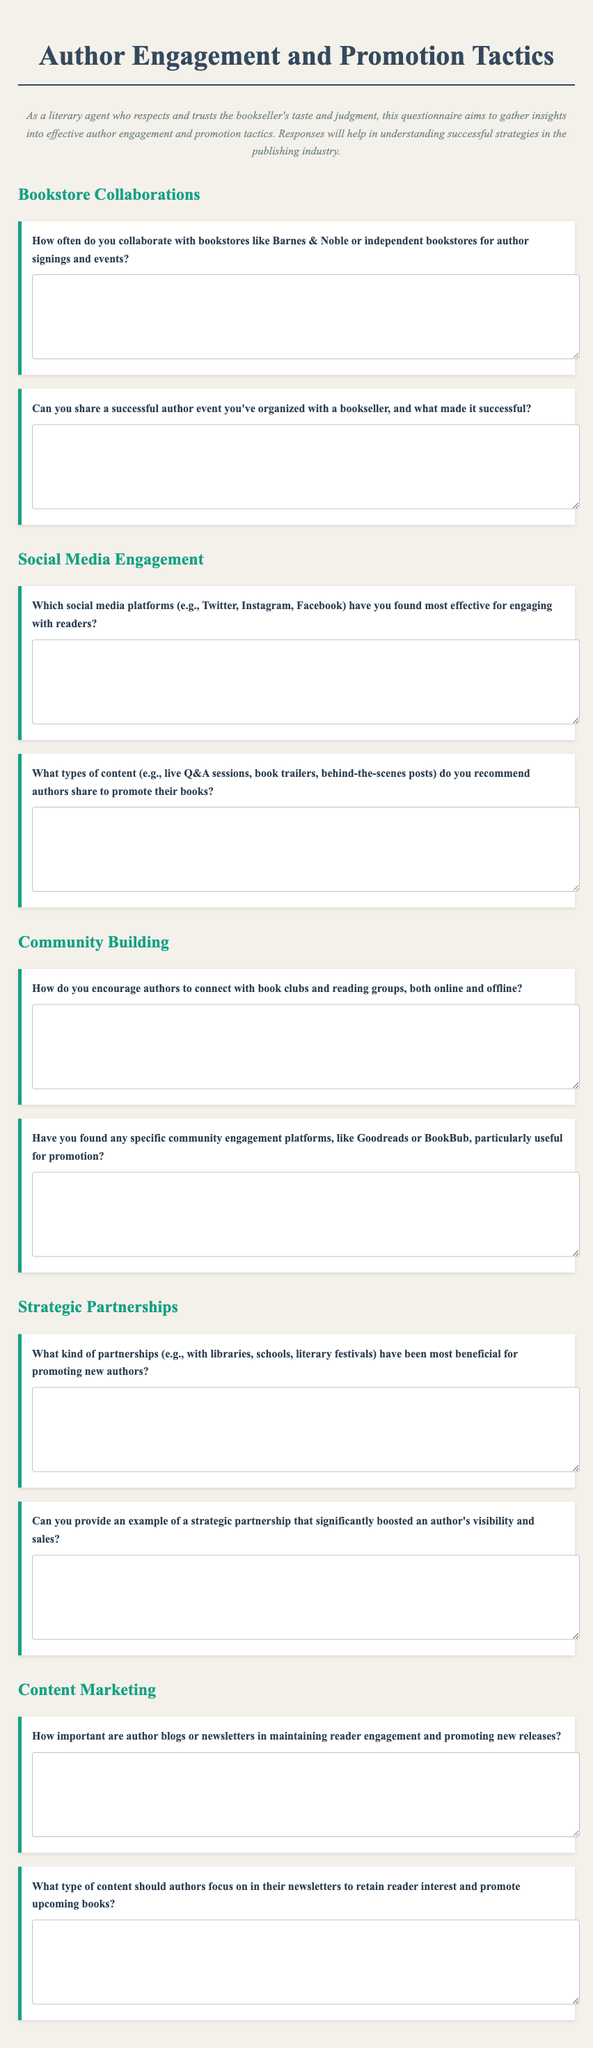What is the title of the questionnaire? The title is clearly stated at the top of the document.
Answer: Author Engagement and Promotion Tactics How many sections are in the questionnaire? The sections are defined by the headers, and there are five distinct sections.
Answer: Five What color is used for the section headings? The color is specified for the styling of section headers in the document.
Answer: #16a085 What is the purpose of the questionnaire? The purpose is explained in the description section of the document.
Answer: To gather insights into effective author engagement and promotion tactics Which social media platforms are mentioned for engagement? The document lists specific social media platforms in one of the questions.
Answer: Twitter, Instagram, Facebook What type of question is “What kind of partnerships have been most beneficial for promoting new authors?” This question’s type relates to gathering information about partnerships in the context of the questionnaire.
Answer: Short-answer What should authors focus on in their newsletters? This is inferred from the question asked regarding newsletter content in the document.
Answer: Content that retains reader interest and promotes upcoming books How is the document styled in terms of font-family? The font-family is specified in the CSS section of the document.
Answer: 'Playfair Display', serif 